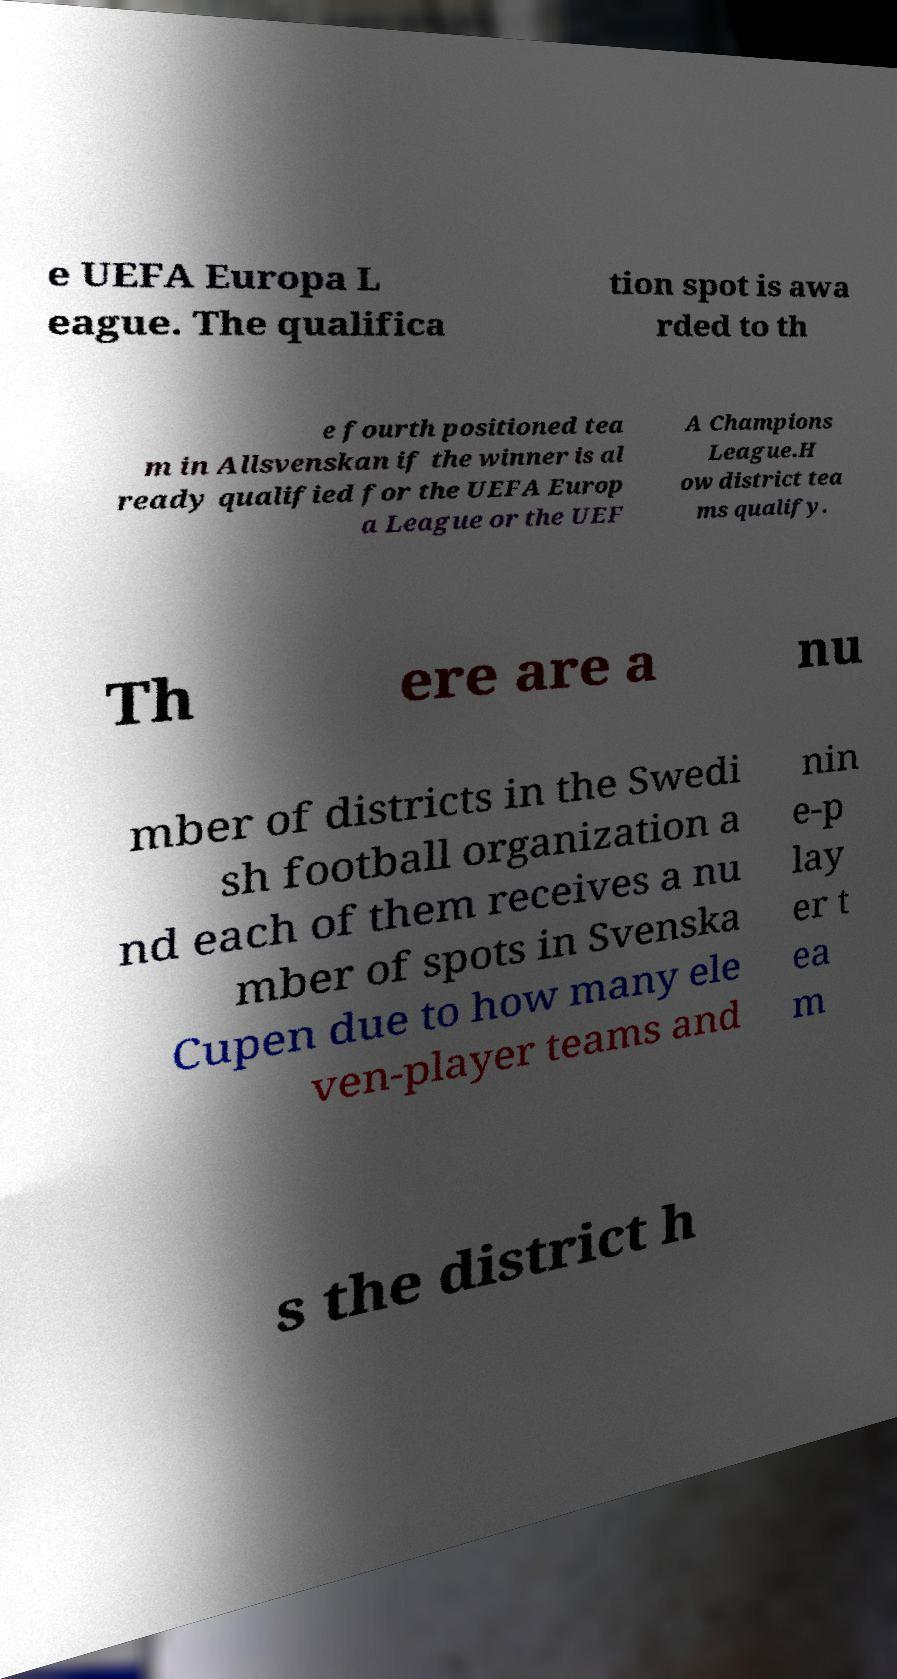Can you read and provide the text displayed in the image?This photo seems to have some interesting text. Can you extract and type it out for me? e UEFA Europa L eague. The qualifica tion spot is awa rded to th e fourth positioned tea m in Allsvenskan if the winner is al ready qualified for the UEFA Europ a League or the UEF A Champions League.H ow district tea ms qualify. Th ere are a nu mber of districts in the Swedi sh football organization a nd each of them receives a nu mber of spots in Svenska Cupen due to how many ele ven-player teams and nin e-p lay er t ea m s the district h 